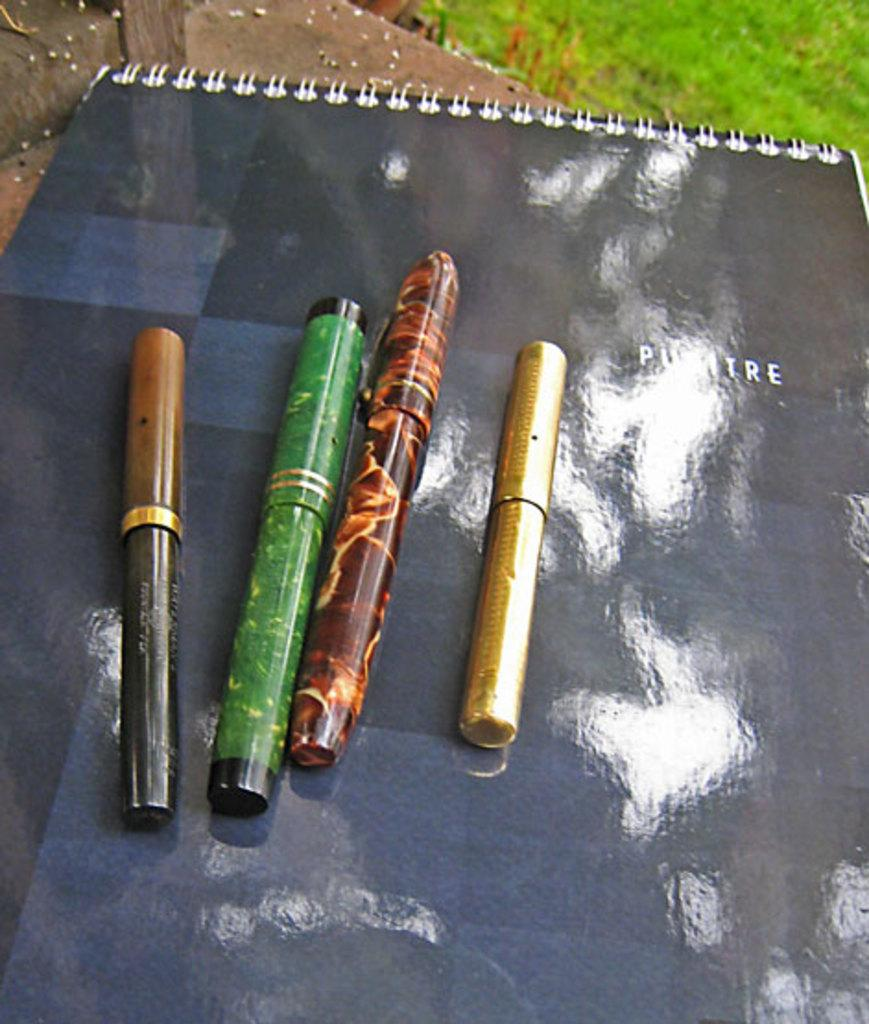How many pens are on the notepad in the image? There are four pens on the notepad in the image. What can be seen in the background of the image? There is grass visible in the background of the image. What type of stocking is being worn by the person in the image? There is no person present in the image, so it is not possible to determine if anyone is wearing a stocking. 